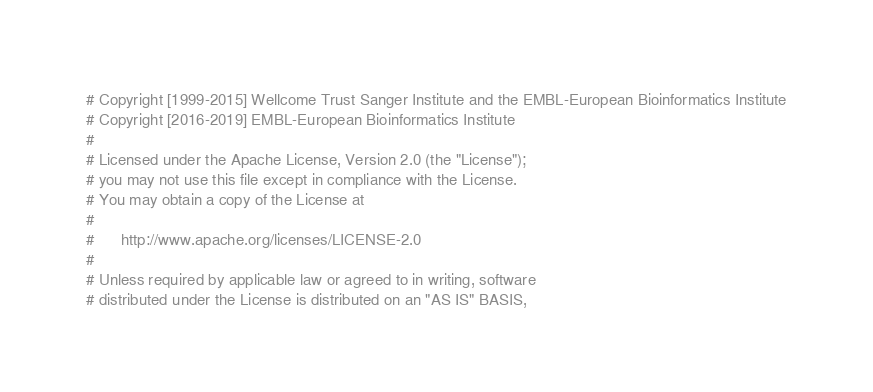<code> <loc_0><loc_0><loc_500><loc_500><_Perl_># Copyright [1999-2015] Wellcome Trust Sanger Institute and the EMBL-European Bioinformatics Institute
# Copyright [2016-2019] EMBL-European Bioinformatics Institute
# 
# Licensed under the Apache License, Version 2.0 (the "License");
# you may not use this file except in compliance with the License.
# You may obtain a copy of the License at
# 
#      http://www.apache.org/licenses/LICENSE-2.0
# 
# Unless required by applicable law or agreed to in writing, software
# distributed under the License is distributed on an "AS IS" BASIS,</code> 